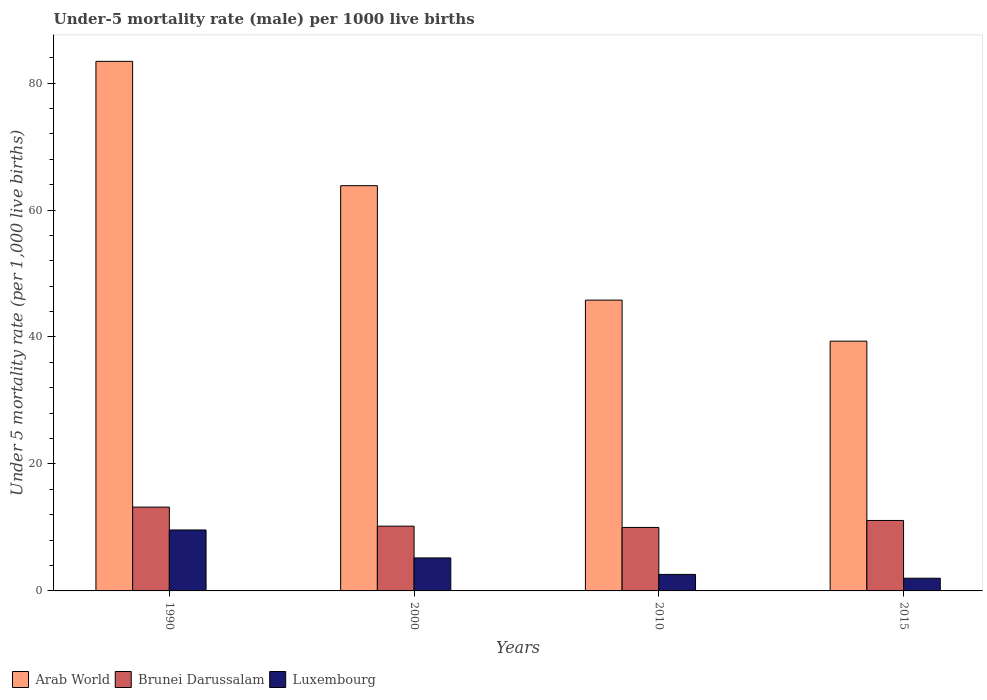Are the number of bars per tick equal to the number of legend labels?
Your answer should be compact. Yes. Are the number of bars on each tick of the X-axis equal?
Your response must be concise. Yes. How many bars are there on the 3rd tick from the right?
Offer a very short reply. 3. What is the label of the 4th group of bars from the left?
Offer a very short reply. 2015. In how many cases, is the number of bars for a given year not equal to the number of legend labels?
Ensure brevity in your answer.  0. What is the under-five mortality rate in Arab World in 2010?
Ensure brevity in your answer.  45.81. Across all years, what is the maximum under-five mortality rate in Luxembourg?
Your answer should be compact. 9.6. In which year was the under-five mortality rate in Arab World minimum?
Provide a succinct answer. 2015. What is the total under-five mortality rate in Brunei Darussalam in the graph?
Give a very brief answer. 44.5. What is the difference between the under-five mortality rate in Arab World in 2000 and that in 2015?
Offer a terse response. 24.49. What is the average under-five mortality rate in Brunei Darussalam per year?
Provide a succinct answer. 11.12. In the year 2000, what is the difference between the under-five mortality rate in Luxembourg and under-five mortality rate in Brunei Darussalam?
Keep it short and to the point. -5. In how many years, is the under-five mortality rate in Luxembourg greater than 8?
Give a very brief answer. 1. What is the ratio of the under-five mortality rate in Brunei Darussalam in 1990 to that in 2015?
Ensure brevity in your answer.  1.19. Is the under-five mortality rate in Luxembourg in 2000 less than that in 2015?
Keep it short and to the point. No. What is the difference between the highest and the second highest under-five mortality rate in Luxembourg?
Provide a succinct answer. 4.4. What is the difference between the highest and the lowest under-five mortality rate in Arab World?
Your answer should be very brief. 44.07. What does the 1st bar from the left in 2015 represents?
Your answer should be compact. Arab World. What does the 3rd bar from the right in 2000 represents?
Provide a short and direct response. Arab World. Is it the case that in every year, the sum of the under-five mortality rate in Arab World and under-five mortality rate in Luxembourg is greater than the under-five mortality rate in Brunei Darussalam?
Your response must be concise. Yes. How many bars are there?
Offer a very short reply. 12. Are all the bars in the graph horizontal?
Your answer should be compact. No. What is the difference between two consecutive major ticks on the Y-axis?
Offer a very short reply. 20. Are the values on the major ticks of Y-axis written in scientific E-notation?
Provide a short and direct response. No. Does the graph contain grids?
Offer a very short reply. No. Where does the legend appear in the graph?
Make the answer very short. Bottom left. How are the legend labels stacked?
Offer a terse response. Horizontal. What is the title of the graph?
Make the answer very short. Under-5 mortality rate (male) per 1000 live births. What is the label or title of the Y-axis?
Your answer should be compact. Under 5 mortality rate (per 1,0 live births). What is the Under 5 mortality rate (per 1,000 live births) of Arab World in 1990?
Make the answer very short. 83.42. What is the Under 5 mortality rate (per 1,000 live births) of Brunei Darussalam in 1990?
Make the answer very short. 13.2. What is the Under 5 mortality rate (per 1,000 live births) of Arab World in 2000?
Provide a succinct answer. 63.83. What is the Under 5 mortality rate (per 1,000 live births) of Brunei Darussalam in 2000?
Offer a terse response. 10.2. What is the Under 5 mortality rate (per 1,000 live births) in Arab World in 2010?
Your response must be concise. 45.81. What is the Under 5 mortality rate (per 1,000 live births) in Brunei Darussalam in 2010?
Your answer should be compact. 10. What is the Under 5 mortality rate (per 1,000 live births) in Luxembourg in 2010?
Make the answer very short. 2.6. What is the Under 5 mortality rate (per 1,000 live births) of Arab World in 2015?
Give a very brief answer. 39.35. What is the Under 5 mortality rate (per 1,000 live births) of Brunei Darussalam in 2015?
Ensure brevity in your answer.  11.1. What is the Under 5 mortality rate (per 1,000 live births) in Luxembourg in 2015?
Your answer should be compact. 2. Across all years, what is the maximum Under 5 mortality rate (per 1,000 live births) in Arab World?
Your answer should be very brief. 83.42. Across all years, what is the maximum Under 5 mortality rate (per 1,000 live births) of Brunei Darussalam?
Keep it short and to the point. 13.2. Across all years, what is the minimum Under 5 mortality rate (per 1,000 live births) of Arab World?
Ensure brevity in your answer.  39.35. Across all years, what is the minimum Under 5 mortality rate (per 1,000 live births) in Luxembourg?
Give a very brief answer. 2. What is the total Under 5 mortality rate (per 1,000 live births) of Arab World in the graph?
Your response must be concise. 232.4. What is the total Under 5 mortality rate (per 1,000 live births) of Brunei Darussalam in the graph?
Ensure brevity in your answer.  44.5. What is the total Under 5 mortality rate (per 1,000 live births) of Luxembourg in the graph?
Keep it short and to the point. 19.4. What is the difference between the Under 5 mortality rate (per 1,000 live births) in Arab World in 1990 and that in 2000?
Offer a terse response. 19.59. What is the difference between the Under 5 mortality rate (per 1,000 live births) in Arab World in 1990 and that in 2010?
Make the answer very short. 37.61. What is the difference between the Under 5 mortality rate (per 1,000 live births) in Brunei Darussalam in 1990 and that in 2010?
Offer a terse response. 3.2. What is the difference between the Under 5 mortality rate (per 1,000 live births) in Luxembourg in 1990 and that in 2010?
Offer a terse response. 7. What is the difference between the Under 5 mortality rate (per 1,000 live births) in Arab World in 1990 and that in 2015?
Make the answer very short. 44.07. What is the difference between the Under 5 mortality rate (per 1,000 live births) in Brunei Darussalam in 1990 and that in 2015?
Offer a very short reply. 2.1. What is the difference between the Under 5 mortality rate (per 1,000 live births) of Luxembourg in 1990 and that in 2015?
Give a very brief answer. 7.6. What is the difference between the Under 5 mortality rate (per 1,000 live births) of Arab World in 2000 and that in 2010?
Your response must be concise. 18.03. What is the difference between the Under 5 mortality rate (per 1,000 live births) of Arab World in 2000 and that in 2015?
Your answer should be very brief. 24.49. What is the difference between the Under 5 mortality rate (per 1,000 live births) in Brunei Darussalam in 2000 and that in 2015?
Provide a short and direct response. -0.9. What is the difference between the Under 5 mortality rate (per 1,000 live births) in Luxembourg in 2000 and that in 2015?
Keep it short and to the point. 3.2. What is the difference between the Under 5 mortality rate (per 1,000 live births) in Arab World in 2010 and that in 2015?
Offer a terse response. 6.46. What is the difference between the Under 5 mortality rate (per 1,000 live births) of Brunei Darussalam in 2010 and that in 2015?
Provide a succinct answer. -1.1. What is the difference between the Under 5 mortality rate (per 1,000 live births) in Arab World in 1990 and the Under 5 mortality rate (per 1,000 live births) in Brunei Darussalam in 2000?
Provide a short and direct response. 73.22. What is the difference between the Under 5 mortality rate (per 1,000 live births) of Arab World in 1990 and the Under 5 mortality rate (per 1,000 live births) of Luxembourg in 2000?
Keep it short and to the point. 78.22. What is the difference between the Under 5 mortality rate (per 1,000 live births) in Brunei Darussalam in 1990 and the Under 5 mortality rate (per 1,000 live births) in Luxembourg in 2000?
Provide a short and direct response. 8. What is the difference between the Under 5 mortality rate (per 1,000 live births) of Arab World in 1990 and the Under 5 mortality rate (per 1,000 live births) of Brunei Darussalam in 2010?
Provide a succinct answer. 73.42. What is the difference between the Under 5 mortality rate (per 1,000 live births) in Arab World in 1990 and the Under 5 mortality rate (per 1,000 live births) in Luxembourg in 2010?
Ensure brevity in your answer.  80.82. What is the difference between the Under 5 mortality rate (per 1,000 live births) of Arab World in 1990 and the Under 5 mortality rate (per 1,000 live births) of Brunei Darussalam in 2015?
Ensure brevity in your answer.  72.32. What is the difference between the Under 5 mortality rate (per 1,000 live births) in Arab World in 1990 and the Under 5 mortality rate (per 1,000 live births) in Luxembourg in 2015?
Give a very brief answer. 81.42. What is the difference between the Under 5 mortality rate (per 1,000 live births) of Brunei Darussalam in 1990 and the Under 5 mortality rate (per 1,000 live births) of Luxembourg in 2015?
Provide a short and direct response. 11.2. What is the difference between the Under 5 mortality rate (per 1,000 live births) in Arab World in 2000 and the Under 5 mortality rate (per 1,000 live births) in Brunei Darussalam in 2010?
Give a very brief answer. 53.83. What is the difference between the Under 5 mortality rate (per 1,000 live births) of Arab World in 2000 and the Under 5 mortality rate (per 1,000 live births) of Luxembourg in 2010?
Provide a short and direct response. 61.23. What is the difference between the Under 5 mortality rate (per 1,000 live births) of Brunei Darussalam in 2000 and the Under 5 mortality rate (per 1,000 live births) of Luxembourg in 2010?
Your answer should be compact. 7.6. What is the difference between the Under 5 mortality rate (per 1,000 live births) of Arab World in 2000 and the Under 5 mortality rate (per 1,000 live births) of Brunei Darussalam in 2015?
Provide a succinct answer. 52.73. What is the difference between the Under 5 mortality rate (per 1,000 live births) in Arab World in 2000 and the Under 5 mortality rate (per 1,000 live births) in Luxembourg in 2015?
Ensure brevity in your answer.  61.83. What is the difference between the Under 5 mortality rate (per 1,000 live births) in Brunei Darussalam in 2000 and the Under 5 mortality rate (per 1,000 live births) in Luxembourg in 2015?
Offer a terse response. 8.2. What is the difference between the Under 5 mortality rate (per 1,000 live births) of Arab World in 2010 and the Under 5 mortality rate (per 1,000 live births) of Brunei Darussalam in 2015?
Your answer should be compact. 34.71. What is the difference between the Under 5 mortality rate (per 1,000 live births) in Arab World in 2010 and the Under 5 mortality rate (per 1,000 live births) in Luxembourg in 2015?
Your response must be concise. 43.81. What is the difference between the Under 5 mortality rate (per 1,000 live births) in Brunei Darussalam in 2010 and the Under 5 mortality rate (per 1,000 live births) in Luxembourg in 2015?
Provide a short and direct response. 8. What is the average Under 5 mortality rate (per 1,000 live births) in Arab World per year?
Your answer should be compact. 58.1. What is the average Under 5 mortality rate (per 1,000 live births) in Brunei Darussalam per year?
Your answer should be compact. 11.12. What is the average Under 5 mortality rate (per 1,000 live births) in Luxembourg per year?
Offer a very short reply. 4.85. In the year 1990, what is the difference between the Under 5 mortality rate (per 1,000 live births) in Arab World and Under 5 mortality rate (per 1,000 live births) in Brunei Darussalam?
Your response must be concise. 70.22. In the year 1990, what is the difference between the Under 5 mortality rate (per 1,000 live births) of Arab World and Under 5 mortality rate (per 1,000 live births) of Luxembourg?
Provide a short and direct response. 73.82. In the year 1990, what is the difference between the Under 5 mortality rate (per 1,000 live births) of Brunei Darussalam and Under 5 mortality rate (per 1,000 live births) of Luxembourg?
Your response must be concise. 3.6. In the year 2000, what is the difference between the Under 5 mortality rate (per 1,000 live births) of Arab World and Under 5 mortality rate (per 1,000 live births) of Brunei Darussalam?
Your response must be concise. 53.63. In the year 2000, what is the difference between the Under 5 mortality rate (per 1,000 live births) of Arab World and Under 5 mortality rate (per 1,000 live births) of Luxembourg?
Give a very brief answer. 58.63. In the year 2000, what is the difference between the Under 5 mortality rate (per 1,000 live births) in Brunei Darussalam and Under 5 mortality rate (per 1,000 live births) in Luxembourg?
Your answer should be very brief. 5. In the year 2010, what is the difference between the Under 5 mortality rate (per 1,000 live births) of Arab World and Under 5 mortality rate (per 1,000 live births) of Brunei Darussalam?
Give a very brief answer. 35.81. In the year 2010, what is the difference between the Under 5 mortality rate (per 1,000 live births) of Arab World and Under 5 mortality rate (per 1,000 live births) of Luxembourg?
Your response must be concise. 43.21. In the year 2015, what is the difference between the Under 5 mortality rate (per 1,000 live births) in Arab World and Under 5 mortality rate (per 1,000 live births) in Brunei Darussalam?
Make the answer very short. 28.25. In the year 2015, what is the difference between the Under 5 mortality rate (per 1,000 live births) in Arab World and Under 5 mortality rate (per 1,000 live births) in Luxembourg?
Your response must be concise. 37.35. In the year 2015, what is the difference between the Under 5 mortality rate (per 1,000 live births) in Brunei Darussalam and Under 5 mortality rate (per 1,000 live births) in Luxembourg?
Provide a succinct answer. 9.1. What is the ratio of the Under 5 mortality rate (per 1,000 live births) of Arab World in 1990 to that in 2000?
Give a very brief answer. 1.31. What is the ratio of the Under 5 mortality rate (per 1,000 live births) in Brunei Darussalam in 1990 to that in 2000?
Offer a very short reply. 1.29. What is the ratio of the Under 5 mortality rate (per 1,000 live births) of Luxembourg in 1990 to that in 2000?
Provide a succinct answer. 1.85. What is the ratio of the Under 5 mortality rate (per 1,000 live births) of Arab World in 1990 to that in 2010?
Provide a succinct answer. 1.82. What is the ratio of the Under 5 mortality rate (per 1,000 live births) of Brunei Darussalam in 1990 to that in 2010?
Ensure brevity in your answer.  1.32. What is the ratio of the Under 5 mortality rate (per 1,000 live births) in Luxembourg in 1990 to that in 2010?
Provide a short and direct response. 3.69. What is the ratio of the Under 5 mortality rate (per 1,000 live births) in Arab World in 1990 to that in 2015?
Offer a very short reply. 2.12. What is the ratio of the Under 5 mortality rate (per 1,000 live births) of Brunei Darussalam in 1990 to that in 2015?
Provide a short and direct response. 1.19. What is the ratio of the Under 5 mortality rate (per 1,000 live births) in Luxembourg in 1990 to that in 2015?
Your response must be concise. 4.8. What is the ratio of the Under 5 mortality rate (per 1,000 live births) in Arab World in 2000 to that in 2010?
Keep it short and to the point. 1.39. What is the ratio of the Under 5 mortality rate (per 1,000 live births) of Brunei Darussalam in 2000 to that in 2010?
Your response must be concise. 1.02. What is the ratio of the Under 5 mortality rate (per 1,000 live births) of Arab World in 2000 to that in 2015?
Your answer should be very brief. 1.62. What is the ratio of the Under 5 mortality rate (per 1,000 live births) of Brunei Darussalam in 2000 to that in 2015?
Ensure brevity in your answer.  0.92. What is the ratio of the Under 5 mortality rate (per 1,000 live births) in Arab World in 2010 to that in 2015?
Provide a succinct answer. 1.16. What is the ratio of the Under 5 mortality rate (per 1,000 live births) of Brunei Darussalam in 2010 to that in 2015?
Provide a succinct answer. 0.9. What is the ratio of the Under 5 mortality rate (per 1,000 live births) of Luxembourg in 2010 to that in 2015?
Ensure brevity in your answer.  1.3. What is the difference between the highest and the second highest Under 5 mortality rate (per 1,000 live births) in Arab World?
Provide a succinct answer. 19.59. What is the difference between the highest and the second highest Under 5 mortality rate (per 1,000 live births) in Brunei Darussalam?
Your response must be concise. 2.1. What is the difference between the highest and the second highest Under 5 mortality rate (per 1,000 live births) of Luxembourg?
Provide a short and direct response. 4.4. What is the difference between the highest and the lowest Under 5 mortality rate (per 1,000 live births) of Arab World?
Keep it short and to the point. 44.07. What is the difference between the highest and the lowest Under 5 mortality rate (per 1,000 live births) in Brunei Darussalam?
Offer a very short reply. 3.2. What is the difference between the highest and the lowest Under 5 mortality rate (per 1,000 live births) of Luxembourg?
Make the answer very short. 7.6. 